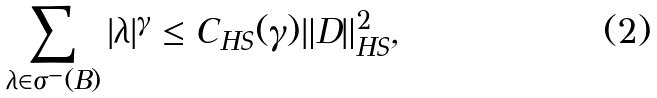Convert formula to latex. <formula><loc_0><loc_0><loc_500><loc_500>\sum _ { \lambda \in \sigma ^ { - } ( B ) } | \lambda | ^ { \gamma } \leq C _ { H S } ( \gamma ) \| D \| _ { H S } ^ { 2 } ,</formula> 